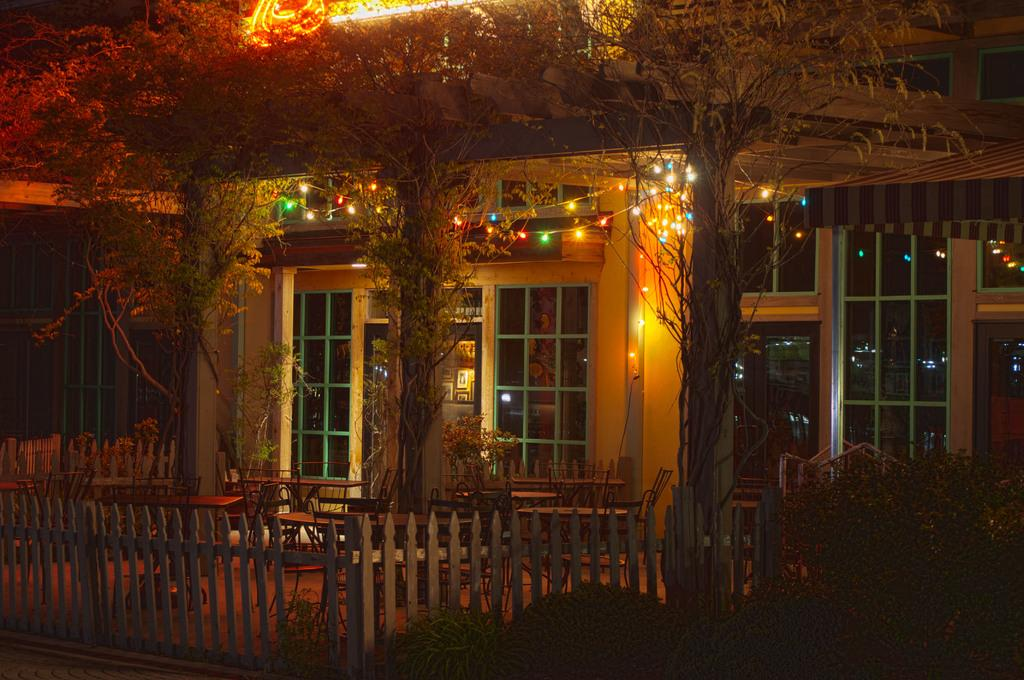What type of house is visible in the image? There is a house with glass windows in the image. What can be seen in the background of the image? There are trees and plants in the image. Are there any artificial light sources visible in the image? Yes, there are lights in the image. What type of fencing is present in the image? There is fencing with wooden sticks in the image. Can you see a feather floating in the air in the image? There is no feather visible in the image. What type of game is being played in the image? There is no game being played in the image. 